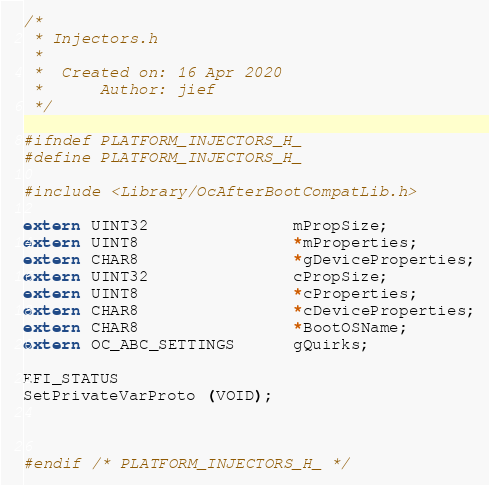Convert code to text. <code><loc_0><loc_0><loc_500><loc_500><_C_>/*
 * Injectors.h
 *
 *  Created on: 16 Apr 2020
 *      Author: jief
 */

#ifndef PLATFORM_INJECTORS_H_
#define PLATFORM_INJECTORS_H_

#include <Library/OcAfterBootCompatLib.h>

extern UINT32               mPropSize;
extern UINT8                *mProperties;
extern CHAR8                *gDeviceProperties;
extern UINT32               cPropSize;
extern UINT8                *cProperties;
extern CHAR8                *cDeviceProperties;
extern CHAR8                *BootOSName;
extern OC_ABC_SETTINGS      gQuirks;

EFI_STATUS
SetPrivateVarProto (VOID);



#endif /* PLATFORM_INJECTORS_H_ */
</code> 